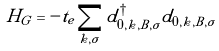Convert formula to latex. <formula><loc_0><loc_0><loc_500><loc_500>H _ { G } = - t _ { e } \sum _ { k , \sigma } d _ { 0 , k , B , \sigma } ^ { \dagger } d _ { 0 , k , B , \sigma }</formula> 